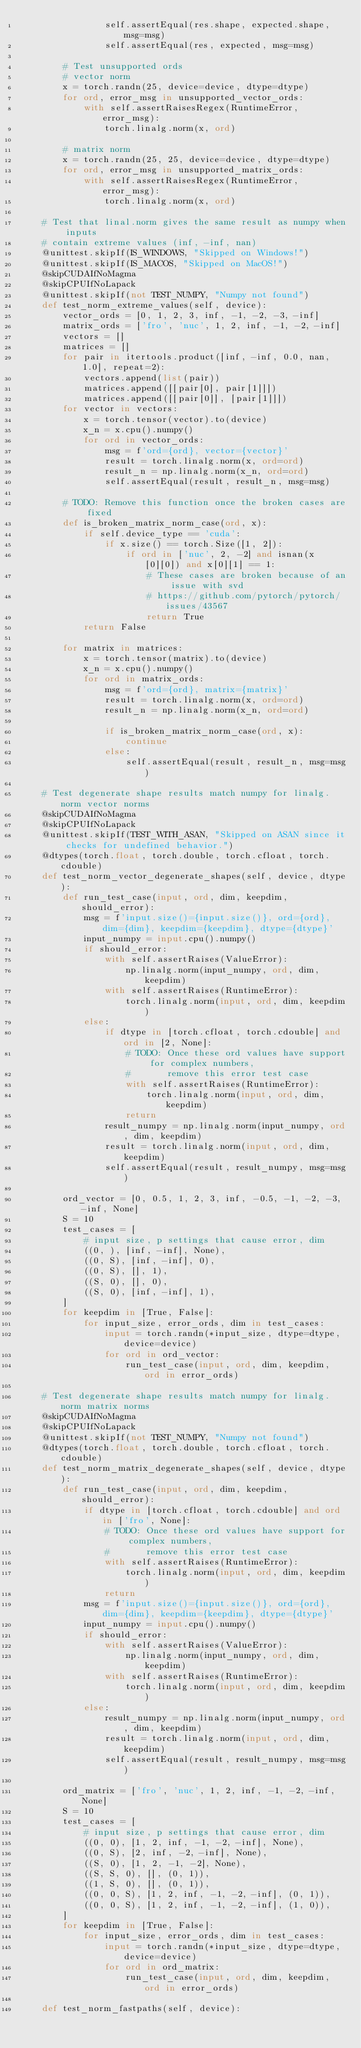Convert code to text. <code><loc_0><loc_0><loc_500><loc_500><_Python_>                self.assertEqual(res.shape, expected.shape, msg=msg)
                self.assertEqual(res, expected, msg=msg)

        # Test unsupported ords
        # vector norm
        x = torch.randn(25, device=device, dtype=dtype)
        for ord, error_msg in unsupported_vector_ords:
            with self.assertRaisesRegex(RuntimeError, error_msg):
                torch.linalg.norm(x, ord)

        # matrix norm
        x = torch.randn(25, 25, device=device, dtype=dtype)
        for ord, error_msg in unsupported_matrix_ords:
            with self.assertRaisesRegex(RuntimeError, error_msg):
                torch.linalg.norm(x, ord)

    # Test that linal.norm gives the same result as numpy when inputs
    # contain extreme values (inf, -inf, nan)
    @unittest.skipIf(IS_WINDOWS, "Skipped on Windows!")
    @unittest.skipIf(IS_MACOS, "Skipped on MacOS!")
    @skipCUDAIfNoMagma
    @skipCPUIfNoLapack
    @unittest.skipIf(not TEST_NUMPY, "Numpy not found")
    def test_norm_extreme_values(self, device):
        vector_ords = [0, 1, 2, 3, inf, -1, -2, -3, -inf]
        matrix_ords = ['fro', 'nuc', 1, 2, inf, -1, -2, -inf]
        vectors = []
        matrices = []
        for pair in itertools.product([inf, -inf, 0.0, nan, 1.0], repeat=2):
            vectors.append(list(pair))
            matrices.append([[pair[0], pair[1]]])
            matrices.append([[pair[0]], [pair[1]]])
        for vector in vectors:
            x = torch.tensor(vector).to(device)
            x_n = x.cpu().numpy()
            for ord in vector_ords:
                msg = f'ord={ord}, vector={vector}'
                result = torch.linalg.norm(x, ord=ord)
                result_n = np.linalg.norm(x_n, ord=ord)
                self.assertEqual(result, result_n, msg=msg)

        # TODO: Remove this function once the broken cases are fixed
        def is_broken_matrix_norm_case(ord, x):
            if self.device_type == 'cuda':
                if x.size() == torch.Size([1, 2]):
                    if ord in ['nuc', 2, -2] and isnan(x[0][0]) and x[0][1] == 1:
                        # These cases are broken because of an issue with svd
                        # https://github.com/pytorch/pytorch/issues/43567
                        return True
            return False

        for matrix in matrices:
            x = torch.tensor(matrix).to(device)
            x_n = x.cpu().numpy()
            for ord in matrix_ords:
                msg = f'ord={ord}, matrix={matrix}'
                result = torch.linalg.norm(x, ord=ord)
                result_n = np.linalg.norm(x_n, ord=ord)

                if is_broken_matrix_norm_case(ord, x):
                    continue
                else:
                    self.assertEqual(result, result_n, msg=msg)

    # Test degenerate shape results match numpy for linalg.norm vector norms
    @skipCUDAIfNoMagma
    @skipCPUIfNoLapack
    @unittest.skipIf(TEST_WITH_ASAN, "Skipped on ASAN since it checks for undefined behavior.")
    @dtypes(torch.float, torch.double, torch.cfloat, torch.cdouble)
    def test_norm_vector_degenerate_shapes(self, device, dtype):
        def run_test_case(input, ord, dim, keepdim, should_error):
            msg = f'input.size()={input.size()}, ord={ord}, dim={dim}, keepdim={keepdim}, dtype={dtype}'
            input_numpy = input.cpu().numpy()
            if should_error:
                with self.assertRaises(ValueError):
                    np.linalg.norm(input_numpy, ord, dim, keepdim)
                with self.assertRaises(RuntimeError):
                    torch.linalg.norm(input, ord, dim, keepdim)
            else:
                if dtype in [torch.cfloat, torch.cdouble] and ord in [2, None]:
                    # TODO: Once these ord values have support for complex numbers,
                    #       remove this error test case
                    with self.assertRaises(RuntimeError):
                        torch.linalg.norm(input, ord, dim, keepdim)
                    return
                result_numpy = np.linalg.norm(input_numpy, ord, dim, keepdim)
                result = torch.linalg.norm(input, ord, dim, keepdim)
                self.assertEqual(result, result_numpy, msg=msg)

        ord_vector = [0, 0.5, 1, 2, 3, inf, -0.5, -1, -2, -3, -inf, None]
        S = 10
        test_cases = [
            # input size, p settings that cause error, dim
            ((0, ), [inf, -inf], None),
            ((0, S), [inf, -inf], 0),
            ((0, S), [], 1),
            ((S, 0), [], 0),
            ((S, 0), [inf, -inf], 1),
        ]
        for keepdim in [True, False]:
            for input_size, error_ords, dim in test_cases:
                input = torch.randn(*input_size, dtype=dtype, device=device)
                for ord in ord_vector:
                    run_test_case(input, ord, dim, keepdim, ord in error_ords)

    # Test degenerate shape results match numpy for linalg.norm matrix norms
    @skipCUDAIfNoMagma
    @skipCPUIfNoLapack
    @unittest.skipIf(not TEST_NUMPY, "Numpy not found")
    @dtypes(torch.float, torch.double, torch.cfloat, torch.cdouble)
    def test_norm_matrix_degenerate_shapes(self, device, dtype):
        def run_test_case(input, ord, dim, keepdim, should_error):
            if dtype in [torch.cfloat, torch.cdouble] and ord in ['fro', None]:
                # TODO: Once these ord values have support for complex numbers,
                #       remove this error test case
                with self.assertRaises(RuntimeError):
                    torch.linalg.norm(input, ord, dim, keepdim)
                return
            msg = f'input.size()={input.size()}, ord={ord}, dim={dim}, keepdim={keepdim}, dtype={dtype}'
            input_numpy = input.cpu().numpy()
            if should_error:
                with self.assertRaises(ValueError):
                    np.linalg.norm(input_numpy, ord, dim, keepdim)
                with self.assertRaises(RuntimeError):
                    torch.linalg.norm(input, ord, dim, keepdim)
            else:
                result_numpy = np.linalg.norm(input_numpy, ord, dim, keepdim)
                result = torch.linalg.norm(input, ord, dim, keepdim)
                self.assertEqual(result, result_numpy, msg=msg)

        ord_matrix = ['fro', 'nuc', 1, 2, inf, -1, -2, -inf, None]
        S = 10
        test_cases = [
            # input size, p settings that cause error, dim
            ((0, 0), [1, 2, inf, -1, -2, -inf], None),
            ((0, S), [2, inf, -2, -inf], None),
            ((S, 0), [1, 2, -1, -2], None),
            ((S, S, 0), [], (0, 1)),
            ((1, S, 0), [], (0, 1)),
            ((0, 0, S), [1, 2, inf, -1, -2, -inf], (0, 1)),
            ((0, 0, S), [1, 2, inf, -1, -2, -inf], (1, 0)),
        ]
        for keepdim in [True, False]:
            for input_size, error_ords, dim in test_cases:
                input = torch.randn(*input_size, dtype=dtype, device=device)
                for ord in ord_matrix:
                    run_test_case(input, ord, dim, keepdim, ord in error_ords)

    def test_norm_fastpaths(self, device):</code> 